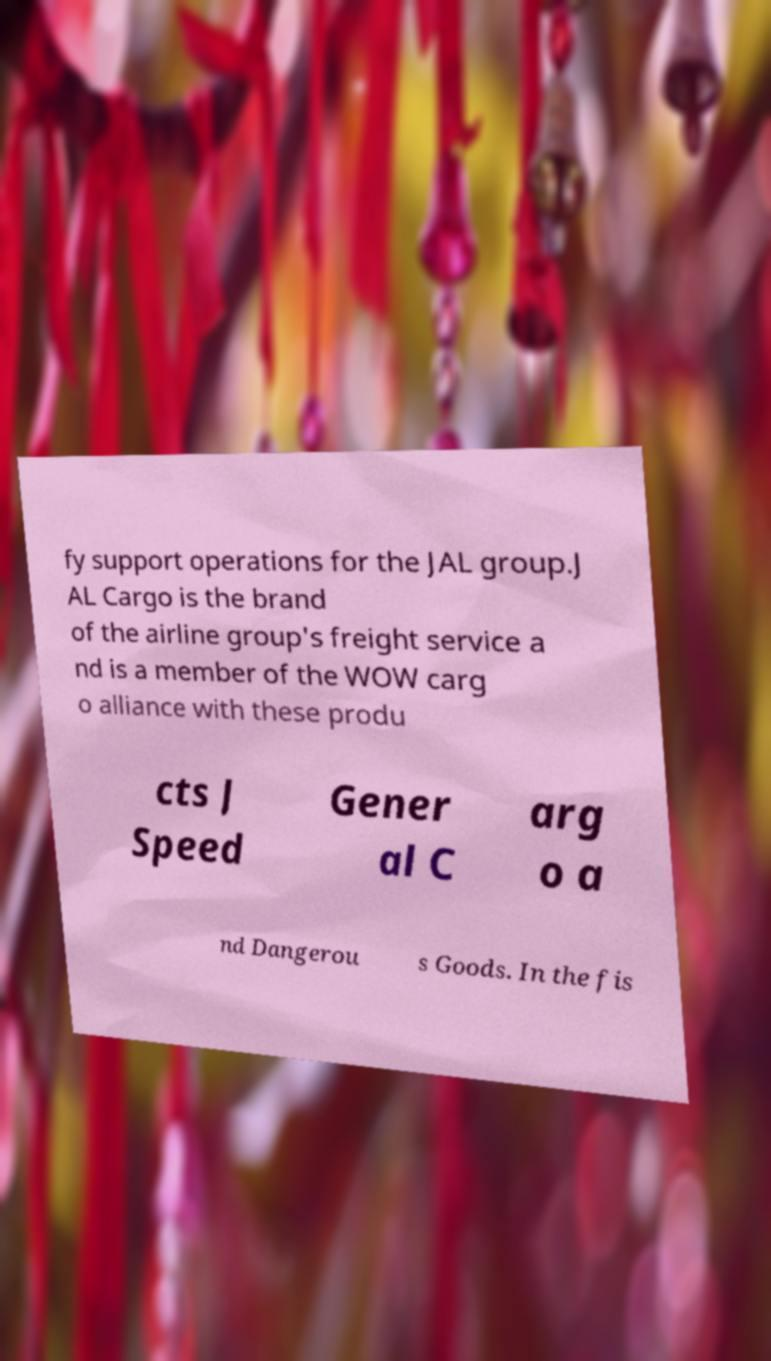For documentation purposes, I need the text within this image transcribed. Could you provide that? fy support operations for the JAL group.J AL Cargo is the brand of the airline group's freight service a nd is a member of the WOW carg o alliance with these produ cts J Speed Gener al C arg o a nd Dangerou s Goods. In the fis 